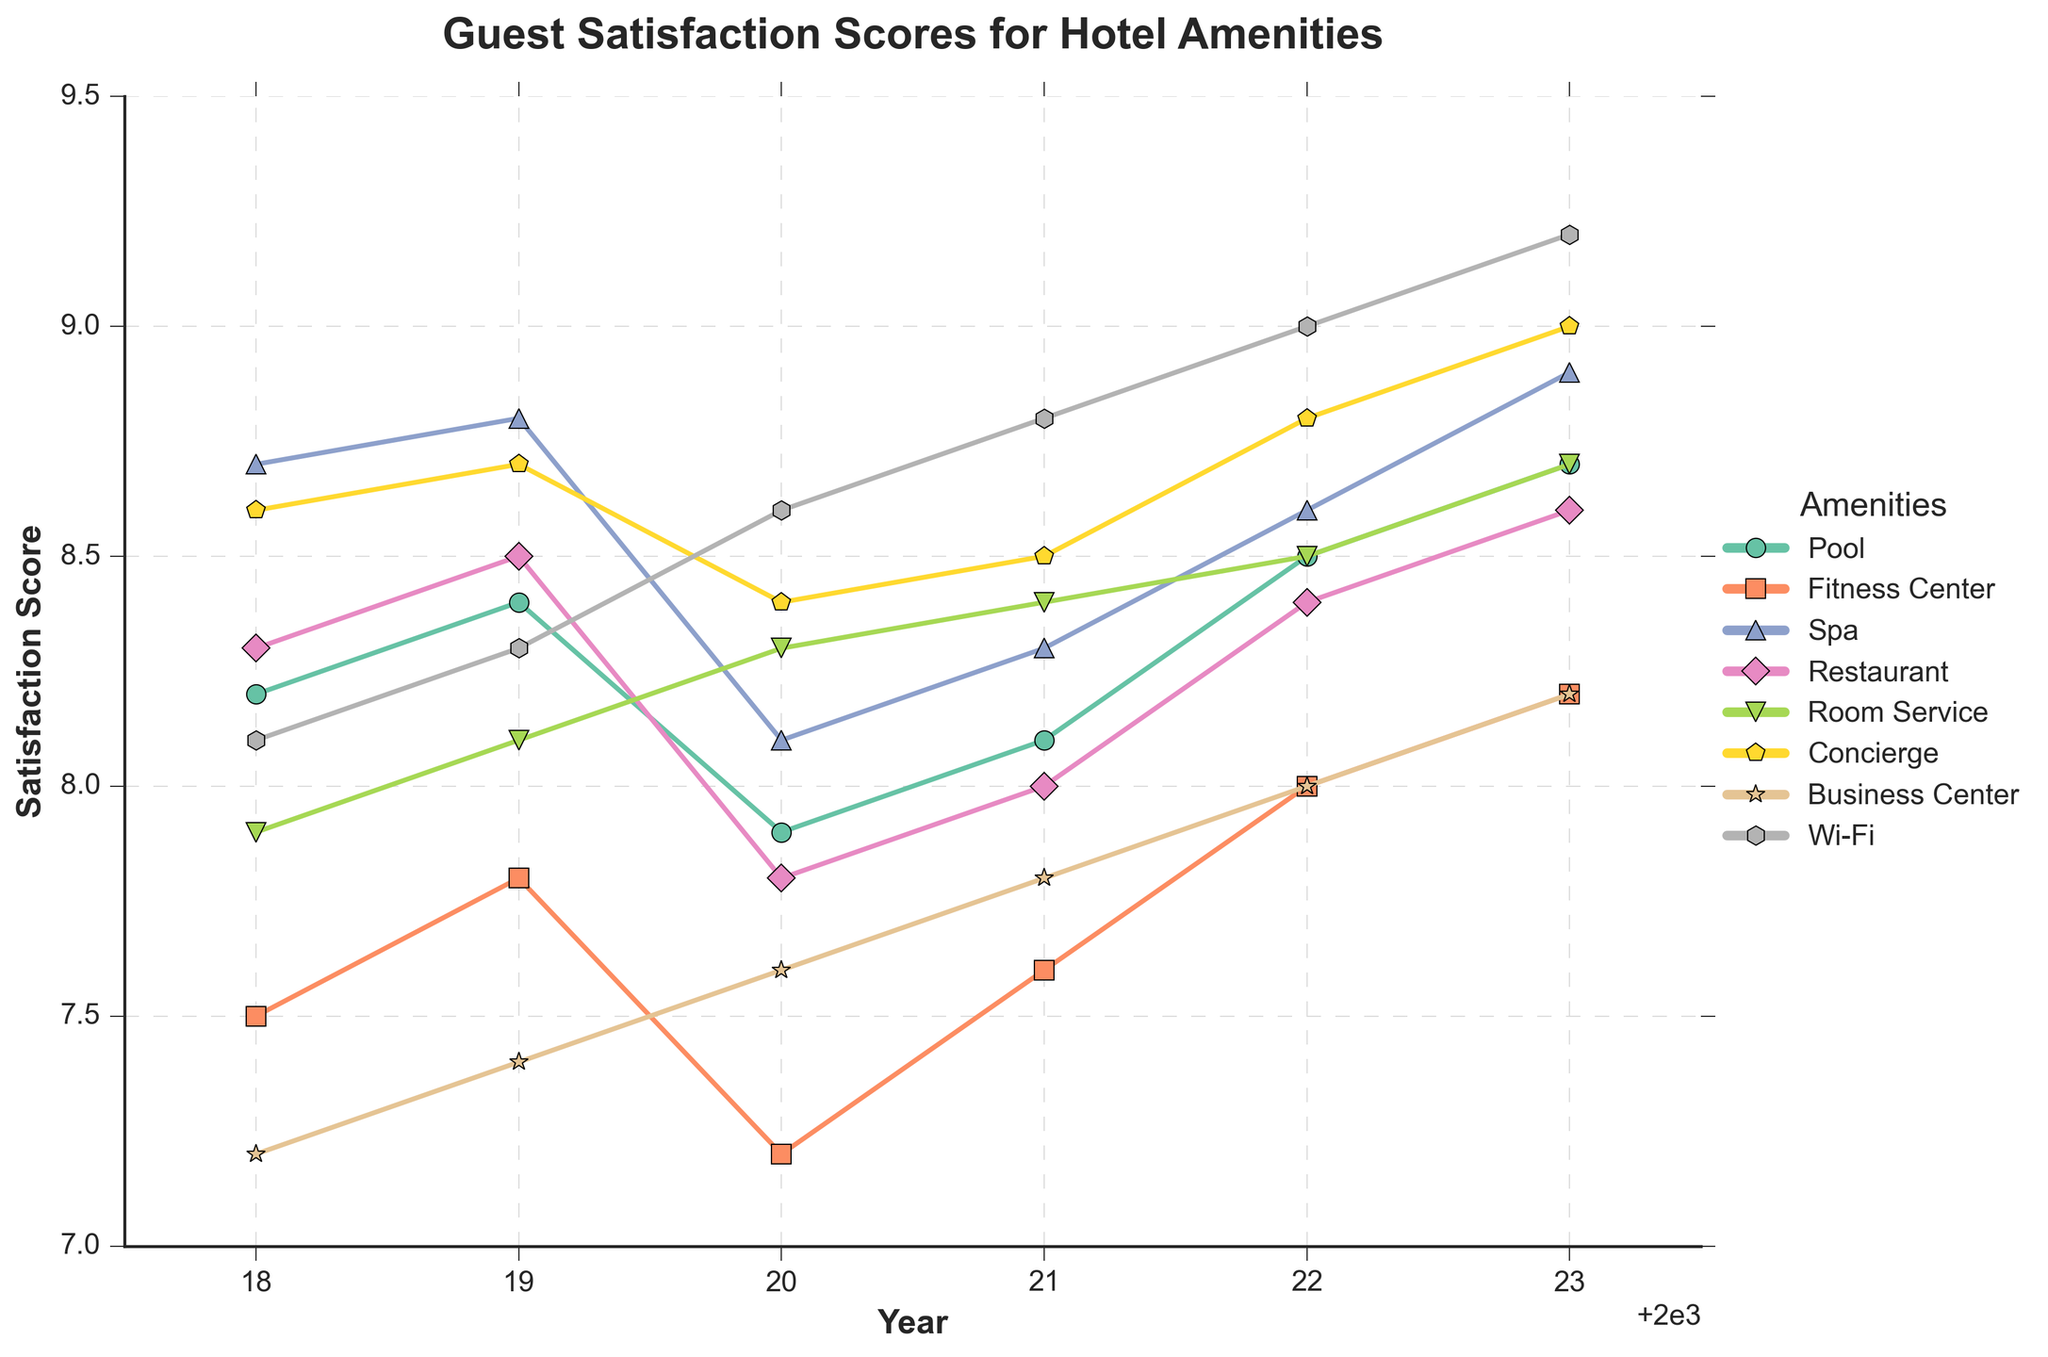Which amenity shows the most improvement in guest satisfaction scores from 2018 to 2023? Identify the satisfaction scores for each amenity in 2018 and 2023. Calculate the difference for each amenity (2023 score - 2018 score). Pool: 8.7 - 8.2 = 0.5, Fitness Center: 8.2 - 7.5 = 0.7, Spa: 8.9 - 8.7 = 0.2, Restaurant: 8.6 - 8.3 = 0.3, Room Service: 8.7 - 7.9 = 0.8, Concierge: 9.0 - 8.6 = 0.4, Business Center: 8.2 - 7.2 = 1.0, Wi-Fi: 9.2 - 8.1 = 1.1. Wi-Fi has the highest increase of 1.1.
Answer: Wi-Fi Which year had the lowest overall guest satisfaction score for the Pool? Reference the plotted line representing Pool and identify the year with the lowest point. The lowest point occurs in 2020 with a score of 7.9.
Answer: 2020 Which amenities showed a consistent increase in satisfaction scores from 2018 to 2023? Observe the plotted lines for each amenity. Pool, Fitness Center, Spa, Room Service, Concierge, Wi-Fi, and Business Center show a generally increasing trend without any drops.
Answer: Pool, Fitness Center, Spa, Room Service, Concierge, Wi-Fi, Business Center By how much did the guest satisfaction score for the Business Center increase from 2019 to 2023? Look at the Business Center's scores for 2019 and 2023. Calculate the difference (2023 score - 2019 score). 8.2 - 7.4 = 0.8.
Answer: 0.8 Which two amenities were rated equally in 2021 and what was their score? Identify scores for 2021 and look for matching values. Both Room Service and Concierge scored 8.5.
Answer: Room Service, Concierge; 8.5 How does the 2023 satisfaction score for the Restaurant compare to that for the Fitness Center? Reference the plotted lines for 2023. Fitness Center scored 8.2 while Restaurant scored 8.6. Restaurant has a higher score.
Answer: Restaurant is higher What is the average satisfaction score for Spa over the years? Calculate the average Spa score: (8.7 + 8.8 + 8.1 + 8.3 + 8.6 + 8.9) / 6 = 8.4.
Answer: 8.4 What trend do you notice in the guest satisfaction scores for Room Service from 2018 to 2023? Observe the plotted line for Room Service. The trend generally increases from 2018 to 2023, with minor fluctuations but ending higher.
Answer: Increasing trend Which amenity had the smallest change in satisfaction scores from 2018 to 2023? Calculate the difference in scores from 2018 to 2023 for each amenity. Spa has the smallest change: 8.9 - 8.7 = 0.2.
Answer: Spa 